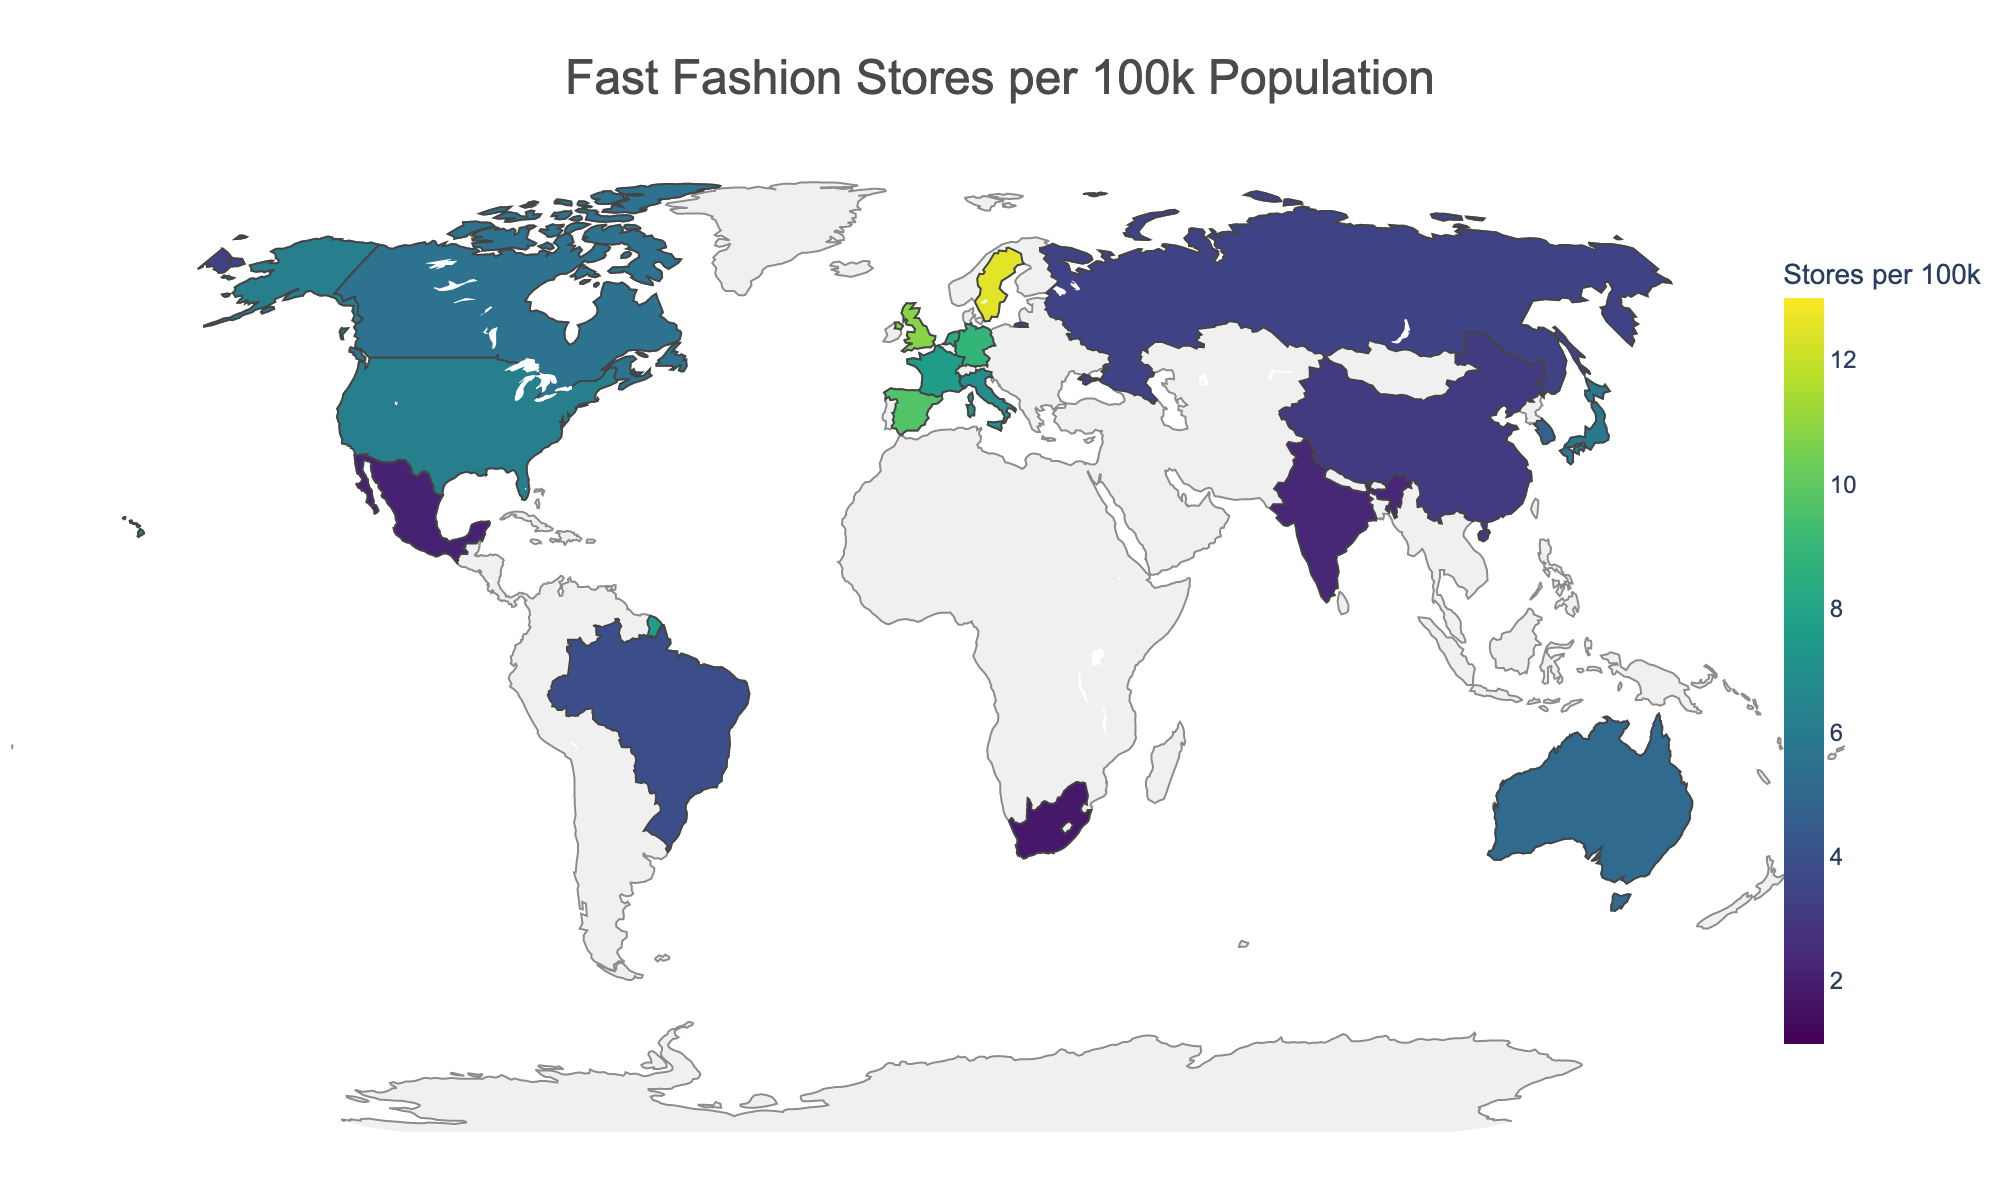What's the title of the plot? The title is displayed at the top of the plot, centered in bold.
Answer: Fast Fashion Stores per 100k Population Which country has the highest concentration of fast fashion stores per 100k population? The highest value is represented by the darkest color in the color scale.
Answer: Sweden What is the concentration of fast fashion stores per 100k population in France? The concentration can be found by locating France on the map and checking its color and/or hover text.
Answer: 7.6 Which two countries have the closest concentration of fast fashion stores per 100k population? By comparing the values visually, you can see that Netherlands (8.3) and France (7.6) have very close concentrations.
Answer: Netherlands and France How many countries have a concentration of less than 4 stores per 100k population? By checking the values, count the countries with concentrations less than 4. There are Brazil (3.9), Russia (3.4), China (3.1), India (2.3), Mexico (2.1), and South Africa (1.8).
Answer: 6 Which continent has the lowest average concentration of fast fashion stores per 100k population? By averaging the values of countries within each continent, identify the continent with the lowest average. Africa has only one country, South Africa, with 1.8.
Answer: Africa Compare the concentrations of fast fashion stores per 100k population between the United States and United Kingdom. Which one is higher, and by how much? By checking the values, the United States has 6.2 and the United Kingdom has 10.8. The difference is 10.8 - 6.2.
Answer: United Kingdom, by 4.6 What is the average concentration of fast fashion stores per 100k population for the top 5 countries? Sum the values of the top 5 countries and divide by 5. The top 5 are Sweden (12.5), United Kingdom (10.8), Spain (9.7), Germany (8.9), and Netherlands (8.3). (12.5 + 10.8 + 9.7 + 8.9 + 8.3) / 5 = 50.2 / 5.
Answer: 10.04 Is the concentration of fast fashion stores in Japan higher or lower than that of Australia? By comparing the values of Japan (5.8) and Australia (5.1), determine if one is higher or lower than the other.
Answer: Higher What color represents countries with the lowest concentration of stores per 100k population, and which are these countries? Locate the lightest color on the color scale. The lightest color represents the lowest value and corresponds to India (2.3), Mexico (2.1), and South Africa (1.8).
Answer: Light yellow, India, Mexico, South Africa 